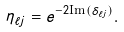Convert formula to latex. <formula><loc_0><loc_0><loc_500><loc_500>\eta _ { \ell j } = e ^ { - 2 \text {Im} ( \delta _ { \ell j } ) } .</formula> 